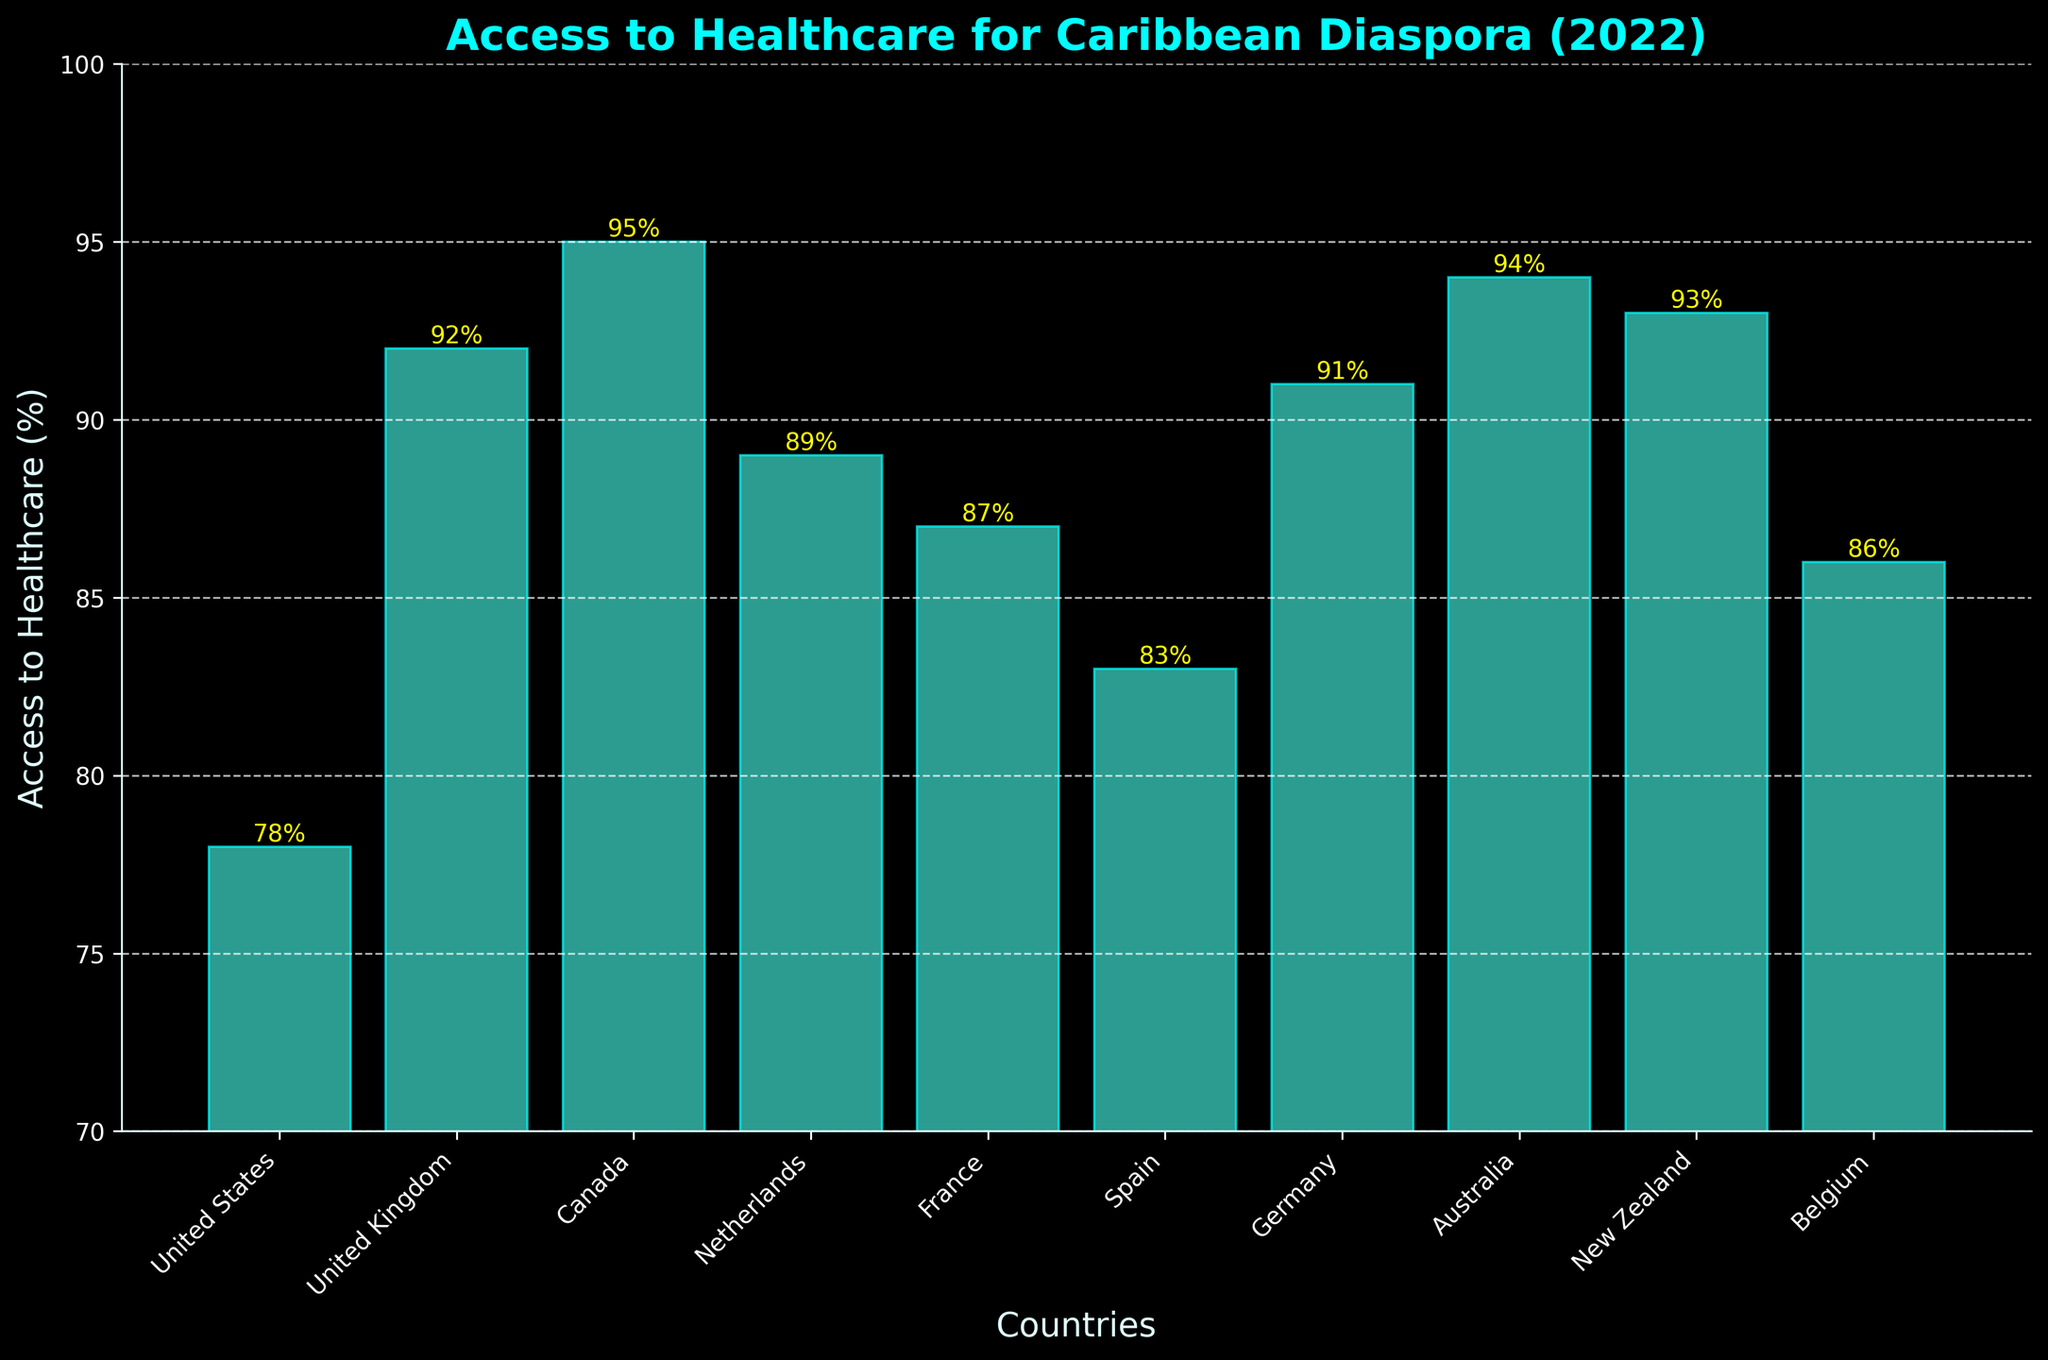Which country has the highest percentage of access to healthcare for the Caribbean diaspora? Upon examining the figure, Canada has the highest bar, indicating the greatest percentage of access to healthcare services.
Answer: Canada Which country has the lowest percentage of access to healthcare for the Caribbean diaspora? The United States has the shortest bar, signifying the lowest percentage of access to healthcare services among the listed countries.
Answer: United States What is the difference in access to healthcare between the United States and Canada for the Caribbean diaspora? Canada's access percentage is 95%, while the United States is 78%. The difference is 95% - 78% = 17%.
Answer: 17% How many countries have an access percentage of 90% or higher? From the figure, the countries with access percentages of 90% or higher are the United Kingdom, Canada, Germany, Australia, and New Zealand. This totals 5 countries.
Answer: 5 What is the average access to healthcare percentage across all the listed countries for the Caribbean diaspora? Summing the percentages: 78 + 92 + 95 + 89 + 87 + 83 + 91 + 94 + 93 + 86 = 888. There are 10 countries, so the average is 888 / 10 = 88.8%.
Answer: 88.8% Which country has a higher access percentage, France or Belgium, and by how much? France has an access percentage of 87%, and Belgium has 86%. The difference is 87% - 86% = 1%.
Answer: France by 1% What are the access percentage values for countries that fall between 80% to 90%? The figure shows that the countries within this range are the United States (78%), Netherlands (89%), France (87%), Spain (83%), and Belgium (86%). However, only Netherlands, France, Spain, and Belgium meet the criteria.
Answer: Netherlands, France, Spain, Belgium What is the sum of access percentages for the United Kingdom and Germany? The access percentage for the United Kingdom is 92%, and for Germany, it is 91%. The sum is 92% + 91% = 183%.
Answer: 183% Which country has the third highest percentage of healthcare access for the Caribbean diaspora? New Zealand has the third highest bar, with an access percentage of 93%, following Canada (95%) and Australia (94%).
Answer: New Zealand Compare the sum and product of access percentages for Australia and New Zealand. Which operation gives a higher result? Australia's access percentage is 94%, and New Zealand's is 93%. The sum is 94% + 93% = 187%. The product is 94% * 93% = 8742%. The product is significantly higher.
Answer: Product 